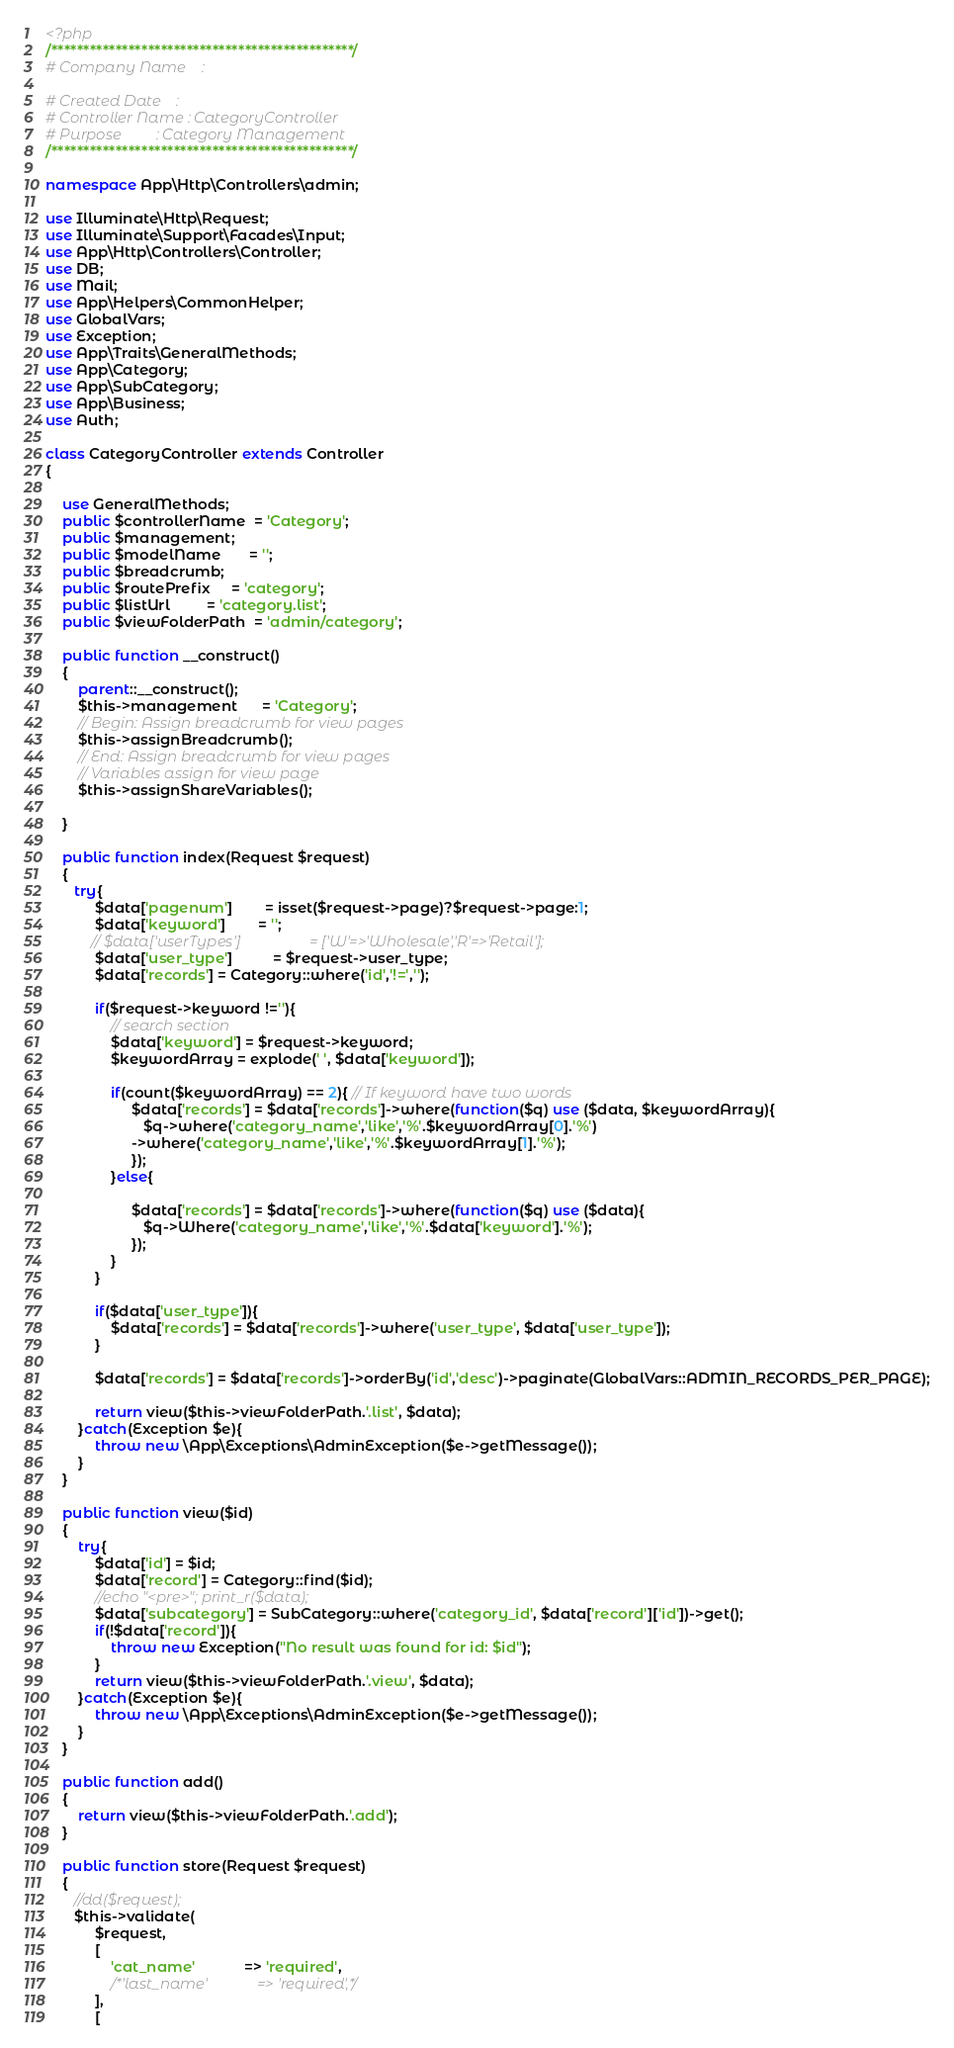<code> <loc_0><loc_0><loc_500><loc_500><_PHP_><?php
/***********************************************/
# Company Name    :                             
                        
# Created Date    :                                
# Controller Name : CategoryController               
# Purpose         : Category Management             
/***********************************************/

namespace App\Http\Controllers\admin;

use Illuminate\Http\Request;
use Illuminate\Support\Facades\Input;
use App\Http\Controllers\Controller;
use DB;
use Mail;
use App\Helpers\CommonHelper;
use GlobalVars;
use Exception;
use App\Traits\GeneralMethods;
use App\Category;
use App\SubCategory;
use App\Business;
use Auth;

class CategoryController extends Controller
{
    
    use GeneralMethods;
    public $controllerName  = 'Category';
    public $management;
    public $modelName       = '';
    public $breadcrumb;
    public $routePrefix     = 'category';
    public $listUrl         = 'category.list';
    public $viewFolderPath  = 'admin/category';
    
    public function __construct()
    {
        parent::__construct();
        $this->management      = 'Category';
        // Begin: Assign breadcrumb for view pages
        $this->assignBreadcrumb();
        // End: Assign breadcrumb for view pages
        // Variables assign for view page
        $this->assignShareVariables();
        
    }
    
    public function index(Request $request)
    {               
       try{
		    $data['pagenum']        = isset($request->page)?$request->page:1;
            $data['keyword']        = '';
           // $data['userTypes']                  = ['W'=>'Wholesale','R'=>'Retail'];
            $data['user_type']          = $request->user_type;
            $data['records'] = Category::where('id','!=','');

            if($request->keyword !=''){
                // search section
                $data['keyword'] = $request->keyword;
                $keywordArray = explode(' ', $data['keyword']);
                
                if(count($keywordArray) == 2){ // If keyword have two words
                     $data['records'] = $data['records']->where(function($q) use ($data, $keywordArray){
                        $q->where('category_name','like','%'.$keywordArray[0].'%')
                     ->where('category_name','like','%'.$keywordArray[1].'%');
                     });                     
                }else{

                     $data['records'] = $data['records']->where(function($q) use ($data){
                        $q->Where('category_name','like','%'.$data['keyword'].'%');
                     });
                }
            }

            if($data['user_type']){
                $data['records'] = $data['records']->where('user_type', $data['user_type']);
            }            

            $data['records'] = $data['records']->orderBy('id','desc')->paginate(GlobalVars::ADMIN_RECORDS_PER_PAGE);

            return view($this->viewFolderPath.'.list', $data);
        }catch(Exception $e){
            throw new \App\Exceptions\AdminException($e->getMessage());
        }
    }

    public function view($id)
    {
        try{ 
            $data['id'] = $id;
			$data['record'] = Category::find($id);
			//echo "<pre>"; print_r($data);
			$data['subcategory'] = SubCategory::where('category_id', $data['record']['id'])->get();
            if(!$data['record']){
                throw new Exception("No result was found for id: $id");
            }	
            return view($this->viewFolderPath.'.view', $data);
        }catch(Exception $e){
            throw new \App\Exceptions\AdminException($e->getMessage());
        }
    } 

    public function add()
    {
        return view($this->viewFolderPath.'.add');
    } 

	public function store(Request $request)
    {
	   //dd($request);
	   $this->validate(
            $request,
            [
                'cat_name'            => 'required',
                /*'last_name'             => 'required',*/
            ],
            [</code> 